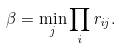Convert formula to latex. <formula><loc_0><loc_0><loc_500><loc_500>\beta = \min _ { j } \prod _ { i } r _ { i j } .</formula> 